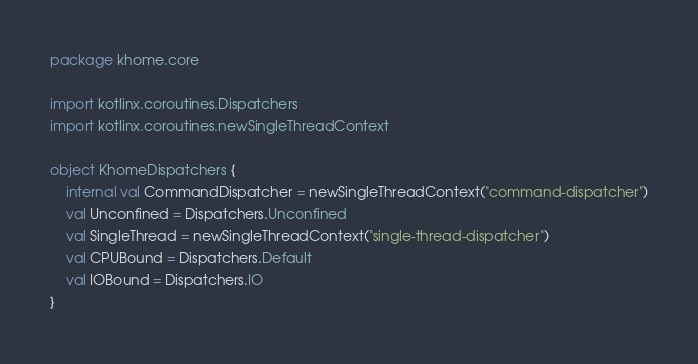Convert code to text. <code><loc_0><loc_0><loc_500><loc_500><_Kotlin_>package khome.core

import kotlinx.coroutines.Dispatchers
import kotlinx.coroutines.newSingleThreadContext

object KhomeDispatchers {
    internal val CommandDispatcher = newSingleThreadContext("command-dispatcher")
    val Unconfined = Dispatchers.Unconfined
    val SingleThread = newSingleThreadContext("single-thread-dispatcher")
    val CPUBound = Dispatchers.Default
    val IOBound = Dispatchers.IO
}
</code> 